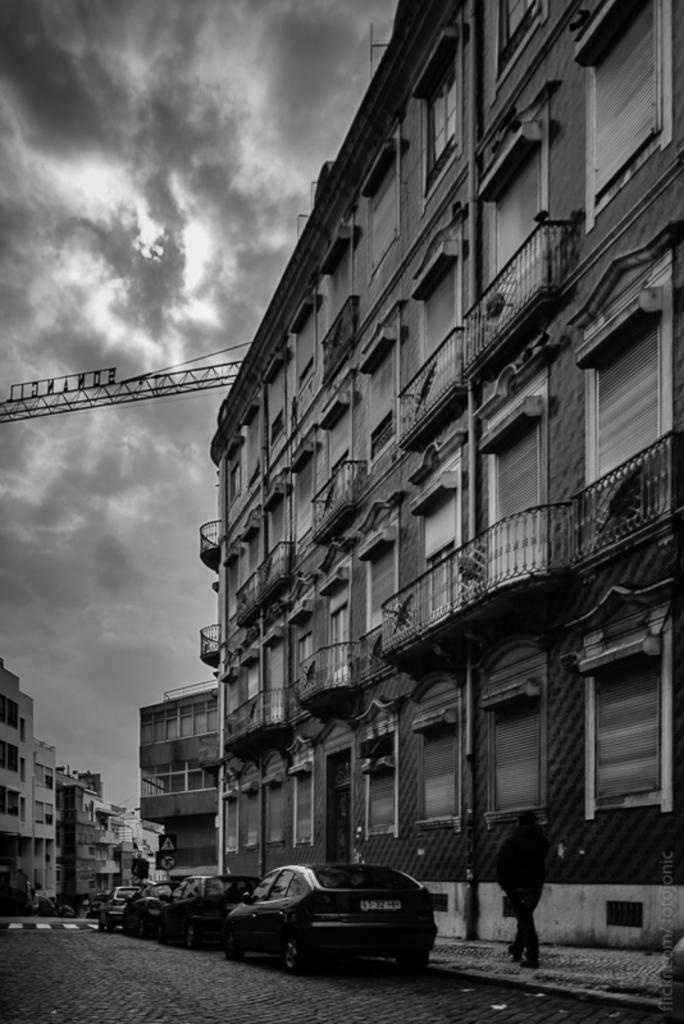What is the color scheme of the image? The image is black and white. What type of vehicles can be seen in the image? There are cars in the image. What structures are located in the middle of the image? There are buildings in the middle of the image. What part of the natural environment is visible in the image? The sky is visible on the left side of the image. What list is being represented by the cars in the image? There is no list being represented by the cars in the image; they are simply vehicles in the scene. 